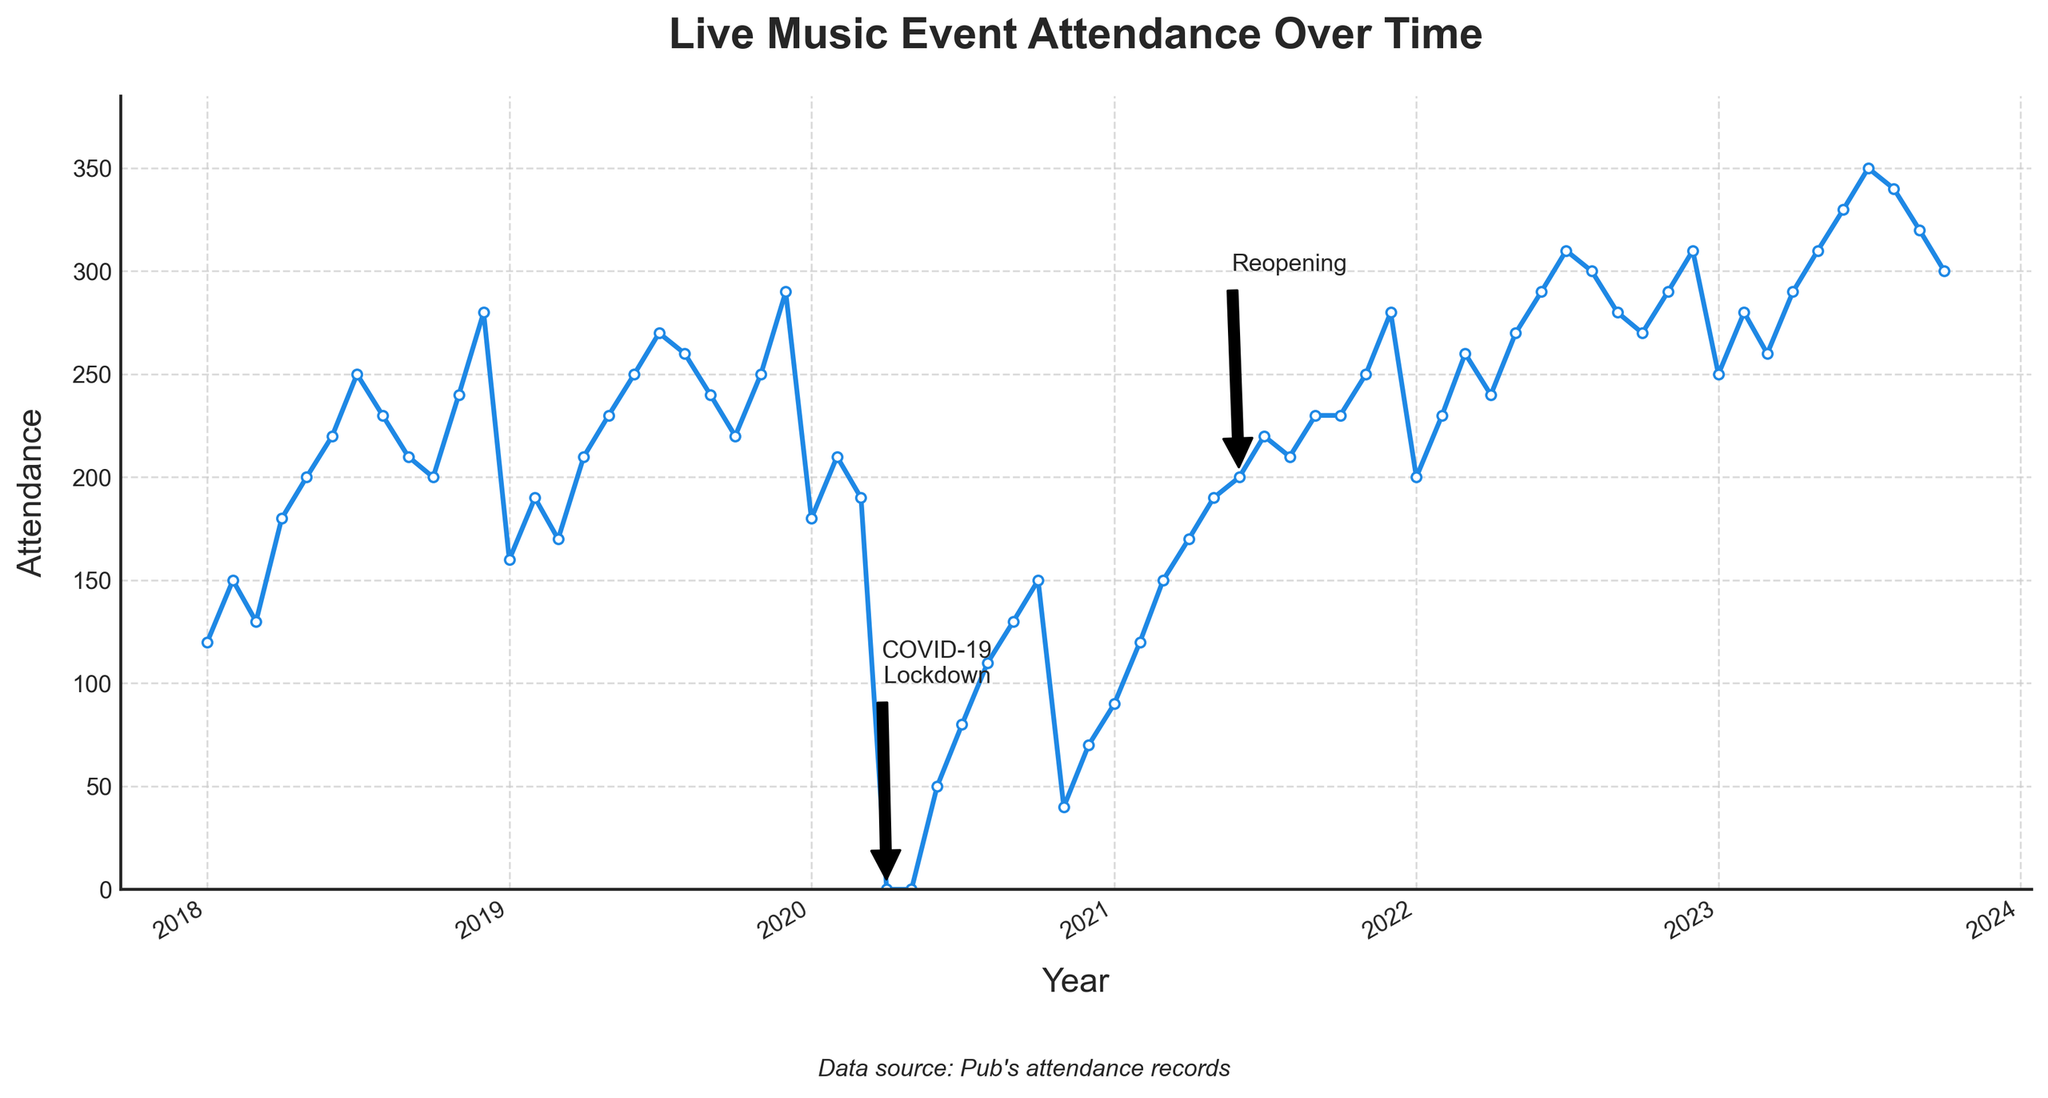How many data points are there in the figure? The plot shows attendance data from January 2018 to October 2023, which totals approximately 70 months of data points, each representing one month
Answer: 70 What is the highest attendance value recorded? The highest attendance is observed around July 2023, at 350 attendees as indicated by the y-axis value
Answer: 350 When was the lowest attendance recorded? The lowest attendance is observed in April and May 2020, during the COVID-19 lockdown, with the attendance being 0
Answer: April 2020 How did the attendance change from January 2020 to February 2020? In January 2020, the attendance was 180. In February 2020, it increased to 210. The difference is 210 - 180 = 30
Answer: Increased by 30 What is the second lowest attendance value recorded and when? The second lowest attendance is recorded in November 2020 with 40 attendees, as observed in the plot
Answer: 40 in November 2020 Compare the attendance value in December 2022 to December 2023. What difference do you observe? The attendance in December 2022 was 310, while the attendance in October 2023 was around 300. The difference is 310 - 300 = 10
Answer: Decreased by 10 During which year did the attendance show a gradually increasing trend recovering from a low? The year 2021 shows a gradual increase from a low in early 2020 due to the COVID-19 lockdowns. The attendance starts to increase steadily from January 2021 onwards
Answer: 2021 What is the average attendance for the year 2018? The total attendance for 2018 is the sum of monthly attendances from January to December, which is 2410. Dividing by 12 months, 2410 / 12 = 200.83
Answer: 200.83 Identify the general trend in attendance from 2018 to 2023. The attendance shows a general increasing trend with significant drops during the COVID-19 lockdowns in 2020 but recovers and continues to rise post-2020
Answer: Increasing Which month in 2023 had the highest attendance and what was the number? The highest attendance in 2023 was in July with 350 attendees
Answer: July 2023 with 350 attendees 